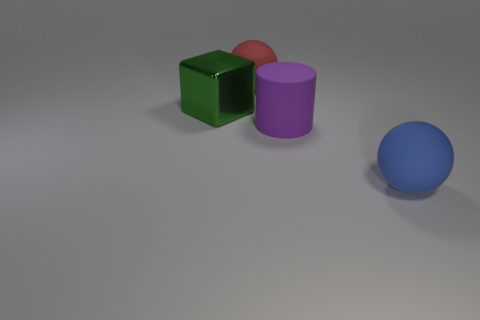How many large things are cylinders or blocks?
Keep it short and to the point. 2. How many other objects are there of the same color as the big shiny object?
Your response must be concise. 0. How many purple things have the same material as the large red sphere?
Offer a very short reply. 1. How many blue objects are shiny objects or big rubber things?
Offer a terse response. 1. Are there any other things that have the same material as the large green block?
Ensure brevity in your answer.  No. Does the large ball behind the blue matte ball have the same material as the cube?
Give a very brief answer. No. What number of things are big cyan metal spheres or large rubber balls behind the big shiny thing?
Your response must be concise. 1. There is a big purple thing in front of the large rubber sphere that is left of the matte cylinder; what number of metallic things are left of it?
Make the answer very short. 1. There is a thing that is behind the large green shiny block; is it the same shape as the blue rubber object?
Give a very brief answer. Yes. Are there any purple matte objects that are to the left of the matte ball that is on the right side of the big cylinder?
Provide a short and direct response. Yes. 